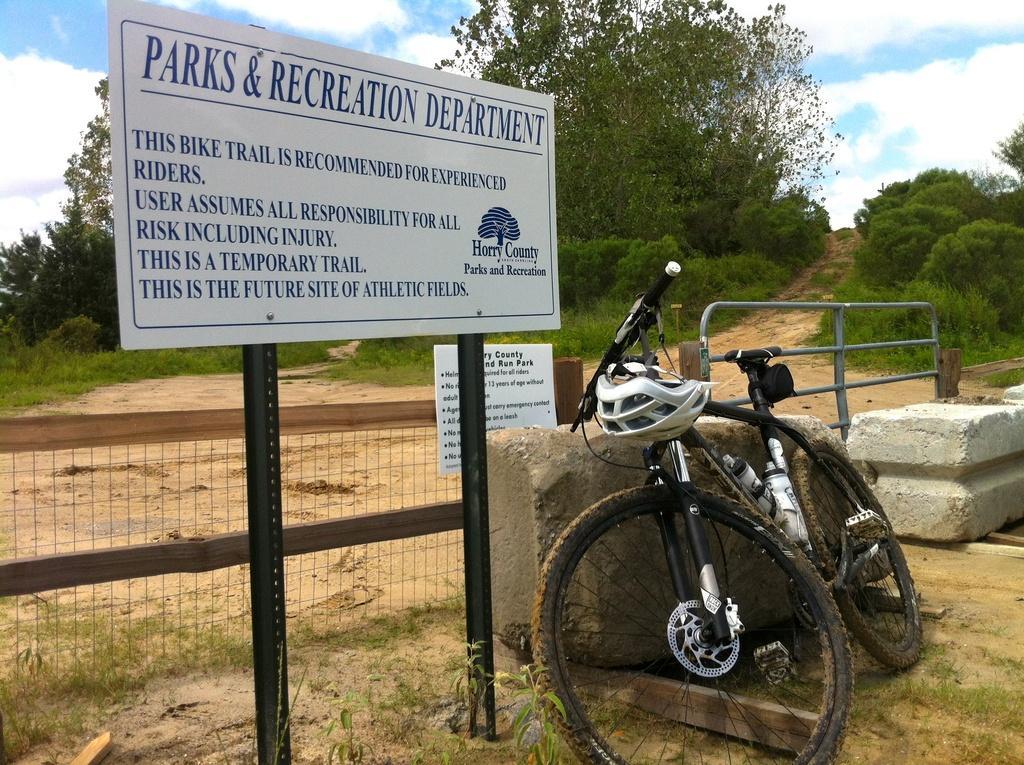Could you give a brief overview of what you see in this image? In this picture we can see a bicycle with a helmet. On the left side of the image, there are poles with a board attached to it. There are cement rocks and a gate. There is another board attached to the fence. Behind the board, there are trees and the sky. 